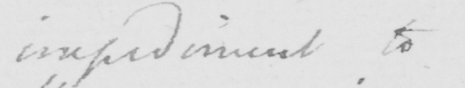What does this handwritten line say? impediment to 